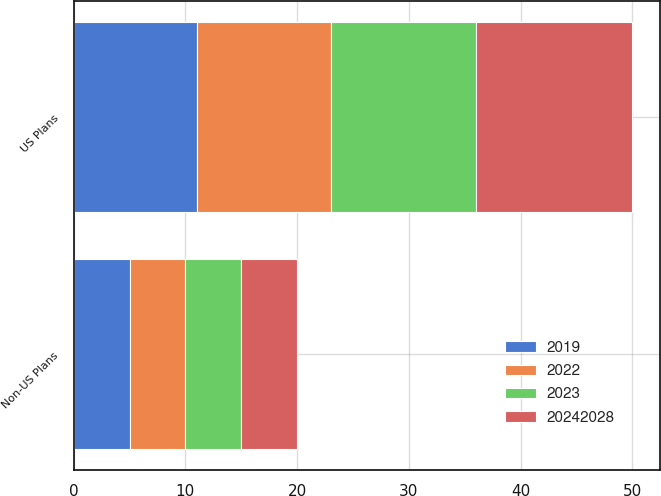<chart> <loc_0><loc_0><loc_500><loc_500><stacked_bar_chart><ecel><fcel>US Plans<fcel>Non-US Plans<nl><fcel>2019<fcel>11<fcel>5<nl><fcel>2022<fcel>12<fcel>5<nl><fcel>2023<fcel>13<fcel>5<nl><fcel>2.0242e+07<fcel>14<fcel>5<nl></chart> 